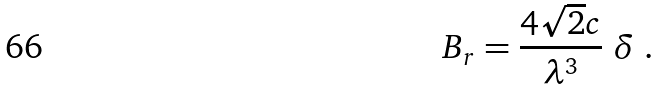<formula> <loc_0><loc_0><loc_500><loc_500>B _ { r } = \frac { 4 \sqrt { 2 } c } { \lambda ^ { 3 } } \ \delta \ .</formula> 